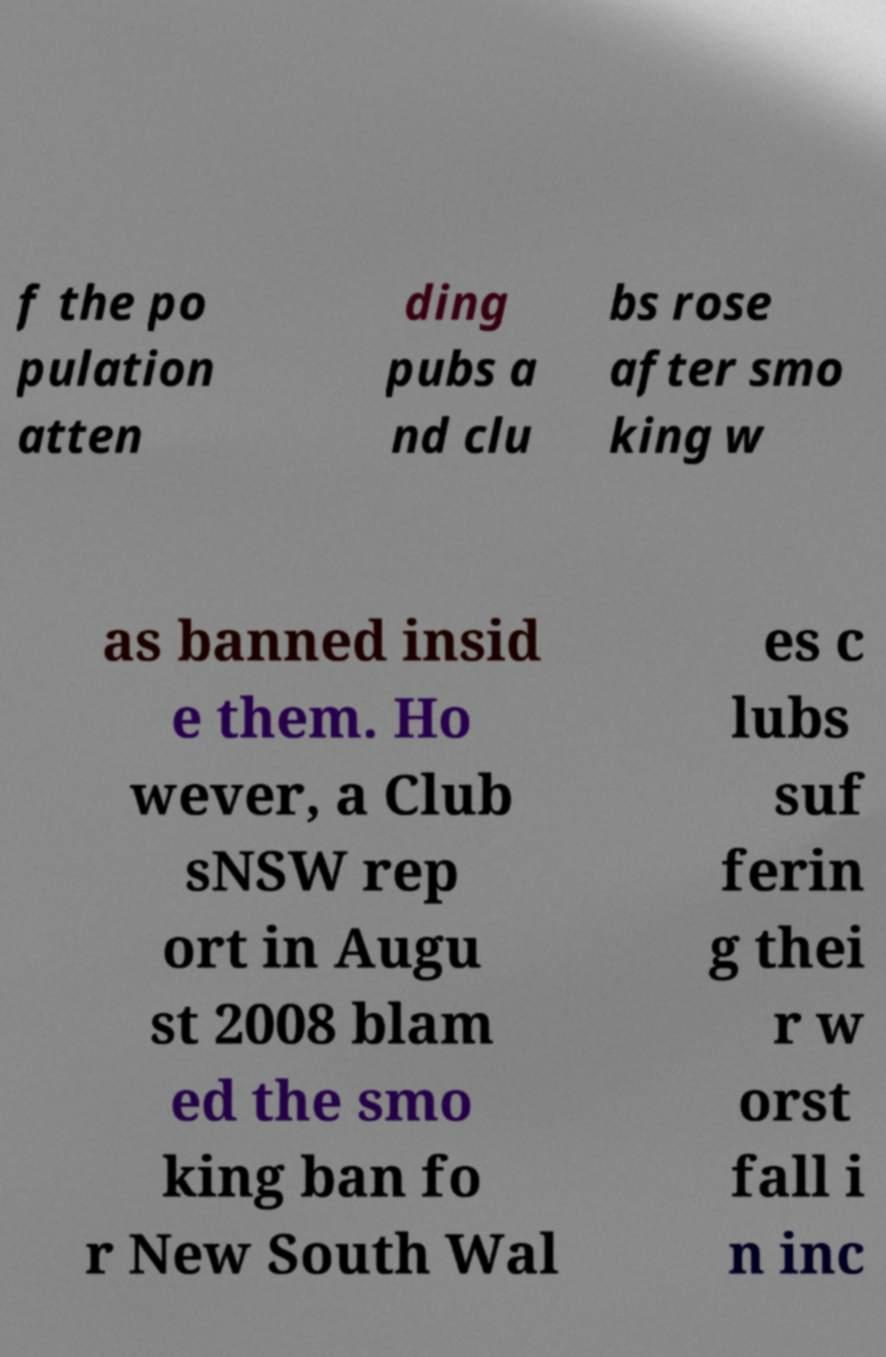Please identify and transcribe the text found in this image. f the po pulation atten ding pubs a nd clu bs rose after smo king w as banned insid e them. Ho wever, a Club sNSW rep ort in Augu st 2008 blam ed the smo king ban fo r New South Wal es c lubs suf ferin g thei r w orst fall i n inc 